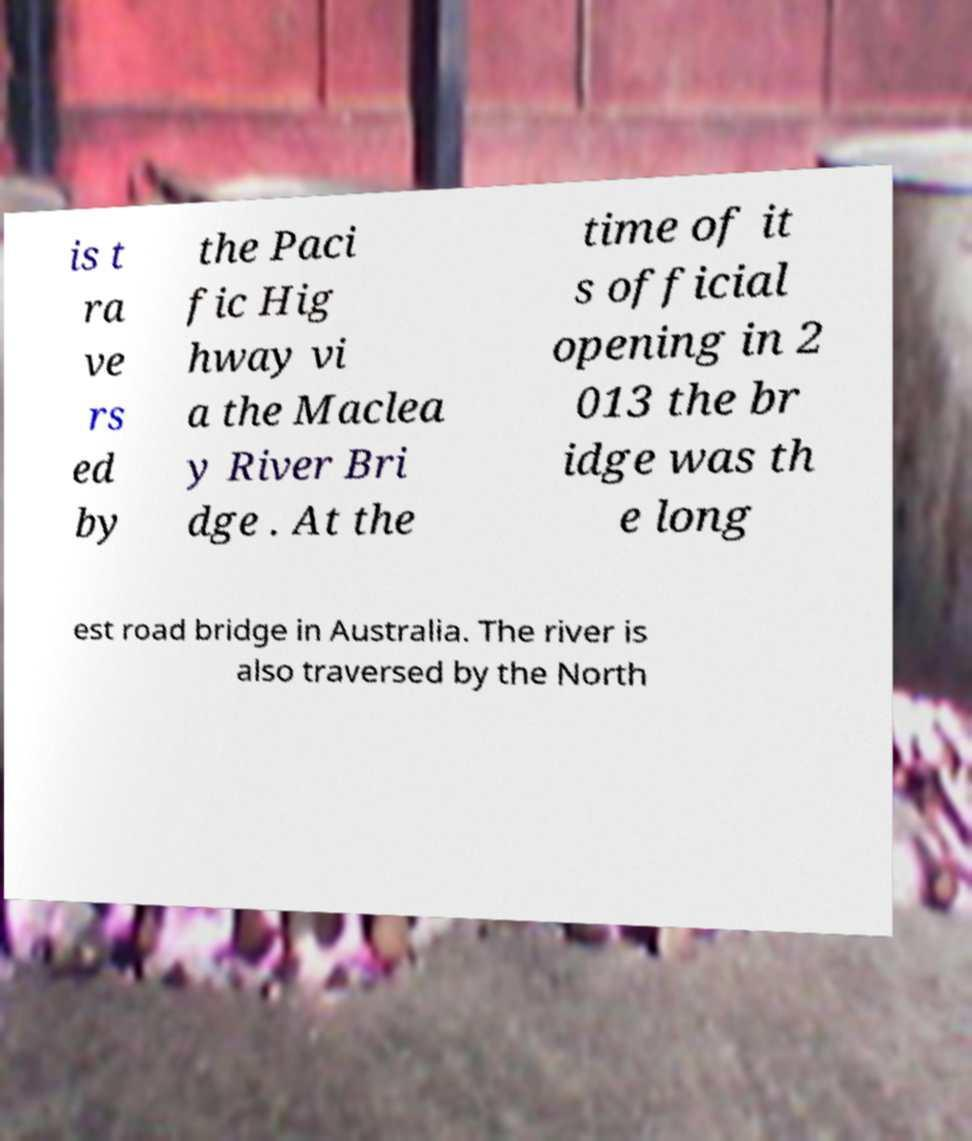Can you accurately transcribe the text from the provided image for me? is t ra ve rs ed by the Paci fic Hig hway vi a the Maclea y River Bri dge . At the time of it s official opening in 2 013 the br idge was th e long est road bridge in Australia. The river is also traversed by the North 